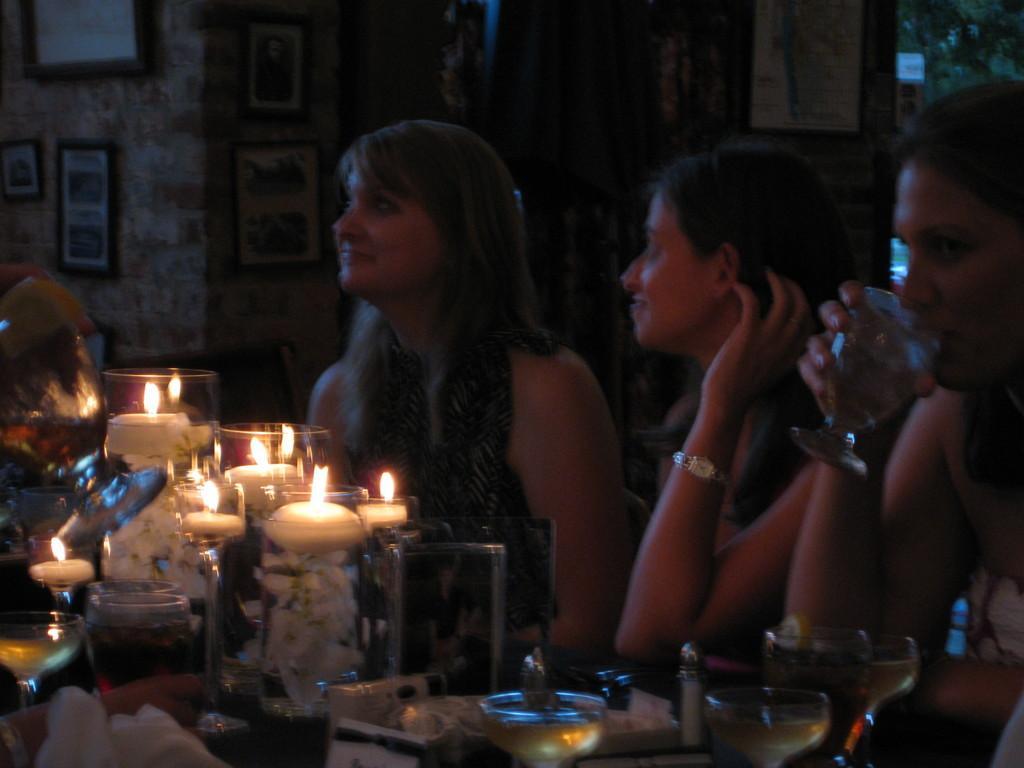In one or two sentences, can you explain what this image depicts? In this picture we can see three women sitting on chairs and drinking with glass and in front of them we can see glasses, candle, tissue paper and in background we can see wall with frames. 